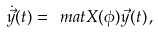<formula> <loc_0><loc_0><loc_500><loc_500>\dot { \vec { y } } ( t ) = \ m a t X ( \phi ) \vec { y } ( t ) \, ,</formula> 